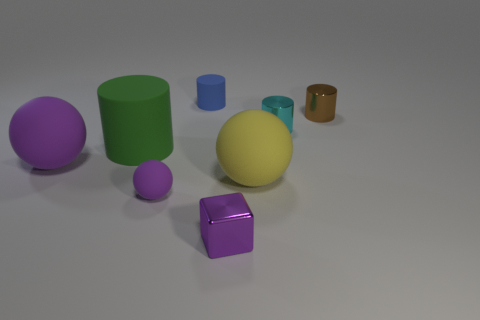There is another rubber sphere that is the same color as the tiny matte sphere; what is its size?
Make the answer very short. Large. There is a small metallic object that is the same color as the tiny rubber ball; what is its shape?
Offer a very short reply. Cube. What is the material of the large ball that is on the left side of the large matte thing to the right of the tiny shiny thing that is on the left side of the cyan cylinder?
Your answer should be compact. Rubber. Does the large yellow thing to the right of the blue object have the same shape as the small purple rubber thing?
Ensure brevity in your answer.  Yes. There is a thing that is on the right side of the small cyan shiny cylinder; what material is it?
Make the answer very short. Metal. What number of metallic things are green objects or large purple things?
Provide a succinct answer. 0. Are there any cyan metallic objects that have the same size as the shiny cube?
Your answer should be very brief. Yes. Are there more tiny things behind the cyan metal thing than blue matte cylinders?
Your answer should be very brief. Yes. What number of tiny objects are either matte things or purple balls?
Offer a very short reply. 2. How many other yellow rubber things have the same shape as the large yellow rubber object?
Provide a short and direct response. 0. 